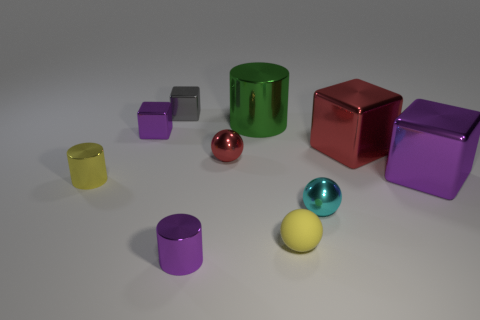Is there any other thing that is made of the same material as the large green cylinder?
Provide a succinct answer. Yes. What shape is the tiny shiny object that is the same color as the tiny rubber thing?
Give a very brief answer. Cylinder. There is a cyan ball; what number of big red cubes are in front of it?
Your answer should be very brief. 0. Are there any gray metallic blocks that have the same size as the purple metallic cylinder?
Offer a terse response. Yes. There is a tiny matte thing that is the same shape as the tiny cyan metal thing; what color is it?
Make the answer very short. Yellow. There is a purple metal thing in front of the yellow metal cylinder; does it have the same size as the purple shiny block that is in front of the red metallic block?
Your answer should be compact. No. Is there another thing of the same shape as the tiny red object?
Your answer should be compact. Yes. Is the number of tiny metal blocks that are in front of the large green metallic object the same as the number of green spheres?
Your response must be concise. No. Is the size of the yellow metal cylinder the same as the purple shiny object that is on the right side of the red ball?
Your response must be concise. No. How many tiny cylinders have the same material as the red sphere?
Provide a succinct answer. 2. 